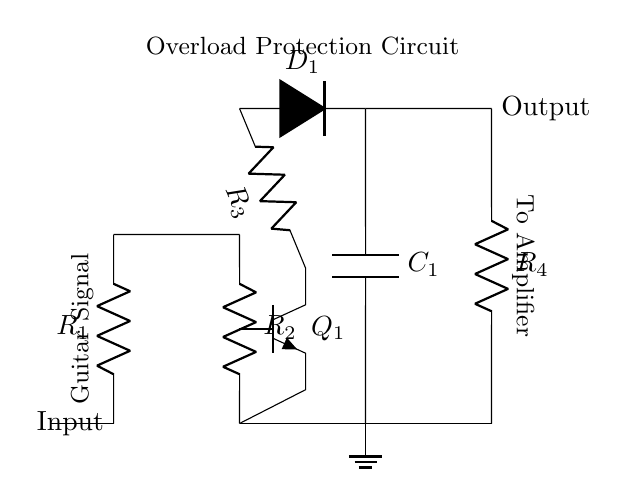What is the input component of the circuit? The input component is a resistor labeled R1, which is connected to the guitar signal.
Answer: R1 What is the function of the transistor Q1? The transistor Q1 acts as a switch or amplifier, controlling the flow of current through the circuit based on the input signal.
Answer: Switch How many resistors are present in the circuit? The circuit contains four resistors: R1, R2, R3, and R4.
Answer: Four What type of protection does this circuit provide? The circuit provides overload protection for the guitar amplifier by limiting excessive current flow.
Answer: Overload protection What happens to the output if the current exceeds safe levels? If the current exceeds safe levels, the transistor Q1 will turn off, stopping the signal flow to prevent damage.
Answer: Signal stops What component is responsible for the discharge in this circuit? The capacitor C1 is responsible for storing charge and discharging it to manage the current effectively.
Answer: C1 What is the purpose of the diode D1 in this circuit? The diode D1 is used to prevent reverse current flow, ensuring the circuit only allows current in one direction.
Answer: Prevents reverse current 